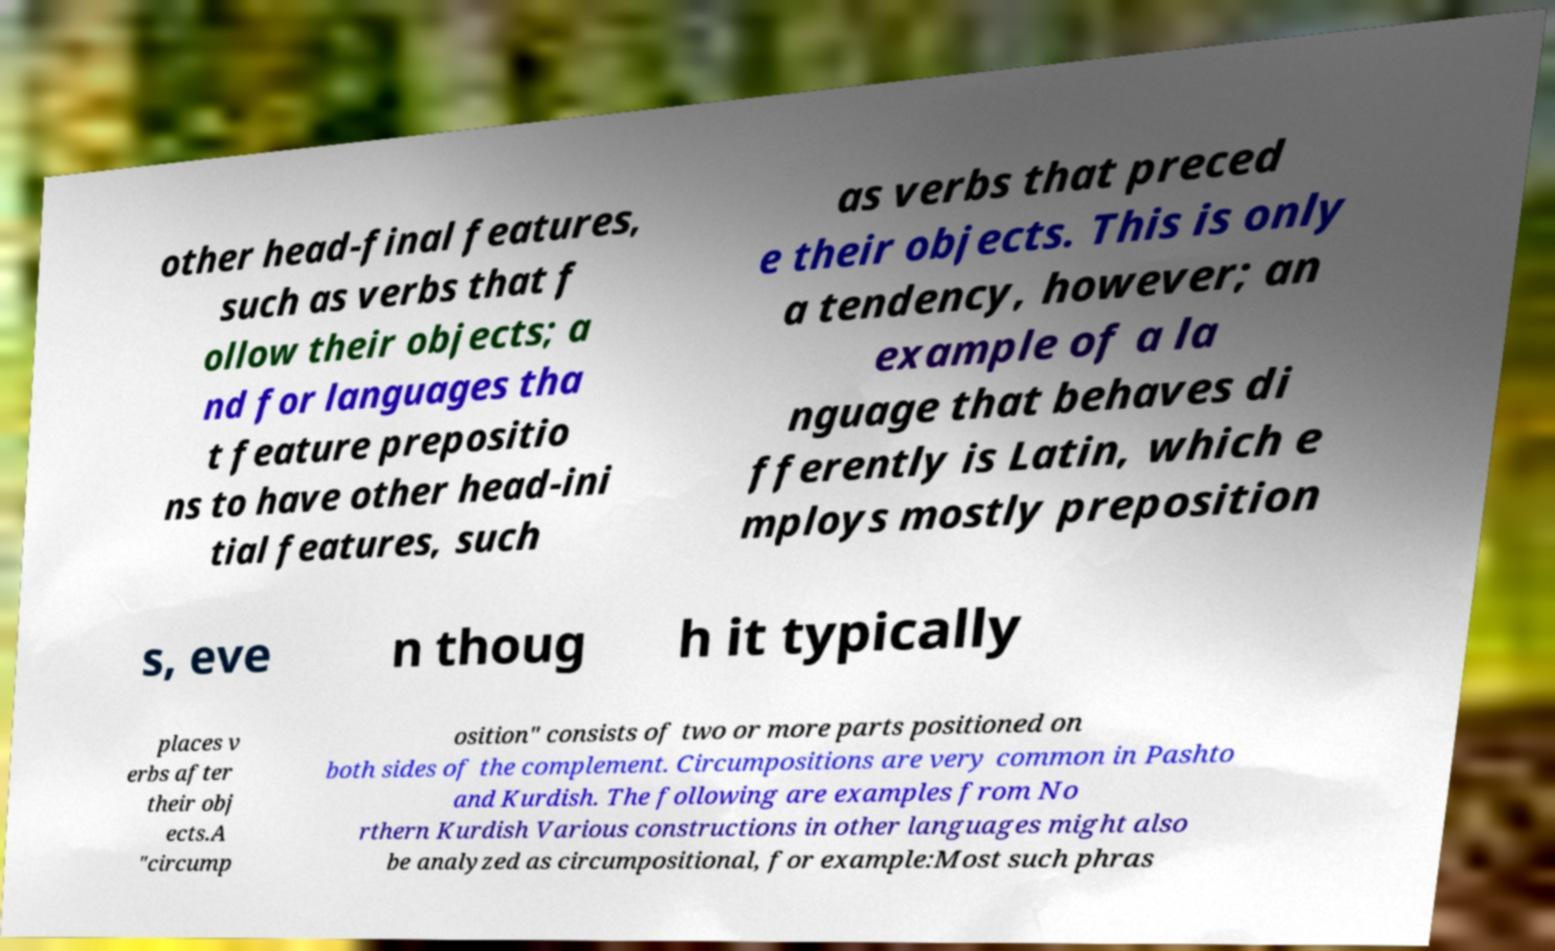I need the written content from this picture converted into text. Can you do that? other head-final features, such as verbs that f ollow their objects; a nd for languages tha t feature prepositio ns to have other head-ini tial features, such as verbs that preced e their objects. This is only a tendency, however; an example of a la nguage that behaves di fferently is Latin, which e mploys mostly preposition s, eve n thoug h it typically places v erbs after their obj ects.A "circump osition" consists of two or more parts positioned on both sides of the complement. Circumpositions are very common in Pashto and Kurdish. The following are examples from No rthern Kurdish Various constructions in other languages might also be analyzed as circumpositional, for example:Most such phras 